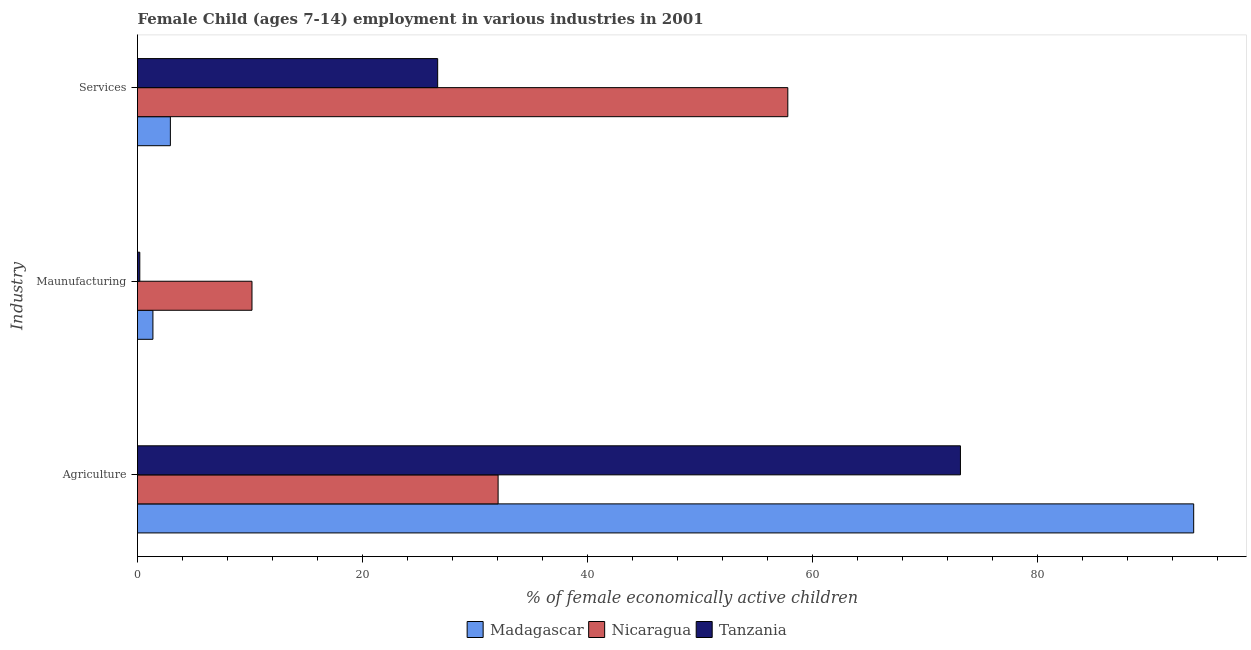Are the number of bars per tick equal to the number of legend labels?
Your answer should be very brief. Yes. What is the label of the 2nd group of bars from the top?
Provide a short and direct response. Maunufacturing. What is the percentage of economically active children in manufacturing in Nicaragua?
Your answer should be compact. 10.17. Across all countries, what is the maximum percentage of economically active children in services?
Ensure brevity in your answer.  57.79. Across all countries, what is the minimum percentage of economically active children in services?
Your answer should be compact. 2.92. In which country was the percentage of economically active children in services maximum?
Give a very brief answer. Nicaragua. In which country was the percentage of economically active children in agriculture minimum?
Your answer should be compact. Nicaragua. What is the total percentage of economically active children in agriculture in the graph?
Make the answer very short. 199.02. What is the difference between the percentage of economically active children in manufacturing in Madagascar and that in Nicaragua?
Offer a very short reply. -8.8. What is the difference between the percentage of economically active children in agriculture in Nicaragua and the percentage of economically active children in services in Madagascar?
Provide a short and direct response. 29.12. What is the average percentage of economically active children in services per country?
Your response must be concise. 29.13. What is the difference between the percentage of economically active children in services and percentage of economically active children in agriculture in Nicaragua?
Your response must be concise. 25.74. In how many countries, is the percentage of economically active children in services greater than 56 %?
Ensure brevity in your answer.  1. What is the ratio of the percentage of economically active children in services in Nicaragua to that in Tanzania?
Give a very brief answer. 2.17. What is the difference between the highest and the second highest percentage of economically active children in agriculture?
Offer a very short reply. 20.73. What is the difference between the highest and the lowest percentage of economically active children in services?
Give a very brief answer. 54.87. Is the sum of the percentage of economically active children in manufacturing in Madagascar and Nicaragua greater than the maximum percentage of economically active children in services across all countries?
Give a very brief answer. No. What does the 2nd bar from the top in Services represents?
Make the answer very short. Nicaragua. What does the 2nd bar from the bottom in Agriculture represents?
Ensure brevity in your answer.  Nicaragua. How many bars are there?
Provide a short and direct response. 9. What is the difference between two consecutive major ticks on the X-axis?
Offer a very short reply. 20. Are the values on the major ticks of X-axis written in scientific E-notation?
Give a very brief answer. No. Does the graph contain grids?
Offer a very short reply. No. Where does the legend appear in the graph?
Your response must be concise. Bottom center. How many legend labels are there?
Provide a succinct answer. 3. How are the legend labels stacked?
Your answer should be very brief. Horizontal. What is the title of the graph?
Provide a short and direct response. Female Child (ages 7-14) employment in various industries in 2001. Does "Malaysia" appear as one of the legend labels in the graph?
Ensure brevity in your answer.  No. What is the label or title of the X-axis?
Your response must be concise. % of female economically active children. What is the label or title of the Y-axis?
Your response must be concise. Industry. What is the % of female economically active children in Madagascar in Agriculture?
Offer a terse response. 93.85. What is the % of female economically active children in Nicaragua in Agriculture?
Your answer should be compact. 32.04. What is the % of female economically active children in Tanzania in Agriculture?
Give a very brief answer. 73.12. What is the % of female economically active children of Madagascar in Maunufacturing?
Offer a very short reply. 1.37. What is the % of female economically active children of Nicaragua in Maunufacturing?
Give a very brief answer. 10.17. What is the % of female economically active children of Tanzania in Maunufacturing?
Your response must be concise. 0.2. What is the % of female economically active children of Madagascar in Services?
Keep it short and to the point. 2.92. What is the % of female economically active children in Nicaragua in Services?
Keep it short and to the point. 57.79. What is the % of female economically active children in Tanzania in Services?
Provide a succinct answer. 26.67. Across all Industry, what is the maximum % of female economically active children of Madagascar?
Provide a succinct answer. 93.85. Across all Industry, what is the maximum % of female economically active children of Nicaragua?
Your answer should be very brief. 57.79. Across all Industry, what is the maximum % of female economically active children of Tanzania?
Your answer should be compact. 73.12. Across all Industry, what is the minimum % of female economically active children of Madagascar?
Offer a terse response. 1.37. Across all Industry, what is the minimum % of female economically active children of Nicaragua?
Your answer should be compact. 10.17. Across all Industry, what is the minimum % of female economically active children in Tanzania?
Give a very brief answer. 0.2. What is the total % of female economically active children in Madagascar in the graph?
Your answer should be compact. 98.14. What is the total % of female economically active children of Nicaragua in the graph?
Give a very brief answer. 100. What is the difference between the % of female economically active children of Madagascar in Agriculture and that in Maunufacturing?
Make the answer very short. 92.48. What is the difference between the % of female economically active children of Nicaragua in Agriculture and that in Maunufacturing?
Your answer should be compact. 21.87. What is the difference between the % of female economically active children of Tanzania in Agriculture and that in Maunufacturing?
Make the answer very short. 72.92. What is the difference between the % of female economically active children of Madagascar in Agriculture and that in Services?
Offer a terse response. 90.93. What is the difference between the % of female economically active children in Nicaragua in Agriculture and that in Services?
Your answer should be very brief. -25.74. What is the difference between the % of female economically active children of Tanzania in Agriculture and that in Services?
Ensure brevity in your answer.  46.45. What is the difference between the % of female economically active children in Madagascar in Maunufacturing and that in Services?
Ensure brevity in your answer.  -1.55. What is the difference between the % of female economically active children of Nicaragua in Maunufacturing and that in Services?
Your answer should be compact. -47.61. What is the difference between the % of female economically active children in Tanzania in Maunufacturing and that in Services?
Your answer should be compact. -26.47. What is the difference between the % of female economically active children of Madagascar in Agriculture and the % of female economically active children of Nicaragua in Maunufacturing?
Your answer should be very brief. 83.68. What is the difference between the % of female economically active children in Madagascar in Agriculture and the % of female economically active children in Tanzania in Maunufacturing?
Ensure brevity in your answer.  93.65. What is the difference between the % of female economically active children of Nicaragua in Agriculture and the % of female economically active children of Tanzania in Maunufacturing?
Your response must be concise. 31.84. What is the difference between the % of female economically active children of Madagascar in Agriculture and the % of female economically active children of Nicaragua in Services?
Your response must be concise. 36.06. What is the difference between the % of female economically active children of Madagascar in Agriculture and the % of female economically active children of Tanzania in Services?
Ensure brevity in your answer.  67.18. What is the difference between the % of female economically active children in Nicaragua in Agriculture and the % of female economically active children in Tanzania in Services?
Keep it short and to the point. 5.37. What is the difference between the % of female economically active children of Madagascar in Maunufacturing and the % of female economically active children of Nicaragua in Services?
Provide a short and direct response. -56.42. What is the difference between the % of female economically active children in Madagascar in Maunufacturing and the % of female economically active children in Tanzania in Services?
Your answer should be compact. -25.3. What is the difference between the % of female economically active children of Nicaragua in Maunufacturing and the % of female economically active children of Tanzania in Services?
Provide a succinct answer. -16.5. What is the average % of female economically active children in Madagascar per Industry?
Keep it short and to the point. 32.71. What is the average % of female economically active children of Nicaragua per Industry?
Provide a succinct answer. 33.33. What is the average % of female economically active children of Tanzania per Industry?
Your answer should be very brief. 33.33. What is the difference between the % of female economically active children in Madagascar and % of female economically active children in Nicaragua in Agriculture?
Offer a terse response. 61.81. What is the difference between the % of female economically active children in Madagascar and % of female economically active children in Tanzania in Agriculture?
Your response must be concise. 20.73. What is the difference between the % of female economically active children in Nicaragua and % of female economically active children in Tanzania in Agriculture?
Your answer should be compact. -41.08. What is the difference between the % of female economically active children of Madagascar and % of female economically active children of Nicaragua in Maunufacturing?
Make the answer very short. -8.8. What is the difference between the % of female economically active children in Madagascar and % of female economically active children in Tanzania in Maunufacturing?
Keep it short and to the point. 1.17. What is the difference between the % of female economically active children in Nicaragua and % of female economically active children in Tanzania in Maunufacturing?
Make the answer very short. 9.97. What is the difference between the % of female economically active children of Madagascar and % of female economically active children of Nicaragua in Services?
Offer a terse response. -54.87. What is the difference between the % of female economically active children of Madagascar and % of female economically active children of Tanzania in Services?
Your answer should be compact. -23.75. What is the difference between the % of female economically active children of Nicaragua and % of female economically active children of Tanzania in Services?
Your response must be concise. 31.11. What is the ratio of the % of female economically active children in Madagascar in Agriculture to that in Maunufacturing?
Give a very brief answer. 68.5. What is the ratio of the % of female economically active children of Nicaragua in Agriculture to that in Maunufacturing?
Give a very brief answer. 3.15. What is the ratio of the % of female economically active children in Tanzania in Agriculture to that in Maunufacturing?
Make the answer very short. 360.16. What is the ratio of the % of female economically active children in Madagascar in Agriculture to that in Services?
Provide a short and direct response. 32.14. What is the ratio of the % of female economically active children in Nicaragua in Agriculture to that in Services?
Offer a very short reply. 0.55. What is the ratio of the % of female economically active children in Tanzania in Agriculture to that in Services?
Your answer should be very brief. 2.74. What is the ratio of the % of female economically active children in Madagascar in Maunufacturing to that in Services?
Give a very brief answer. 0.47. What is the ratio of the % of female economically active children of Nicaragua in Maunufacturing to that in Services?
Your answer should be compact. 0.18. What is the ratio of the % of female economically active children of Tanzania in Maunufacturing to that in Services?
Keep it short and to the point. 0.01. What is the difference between the highest and the second highest % of female economically active children of Madagascar?
Your response must be concise. 90.93. What is the difference between the highest and the second highest % of female economically active children in Nicaragua?
Your answer should be very brief. 25.74. What is the difference between the highest and the second highest % of female economically active children of Tanzania?
Give a very brief answer. 46.45. What is the difference between the highest and the lowest % of female economically active children of Madagascar?
Make the answer very short. 92.48. What is the difference between the highest and the lowest % of female economically active children of Nicaragua?
Make the answer very short. 47.61. What is the difference between the highest and the lowest % of female economically active children in Tanzania?
Give a very brief answer. 72.92. 